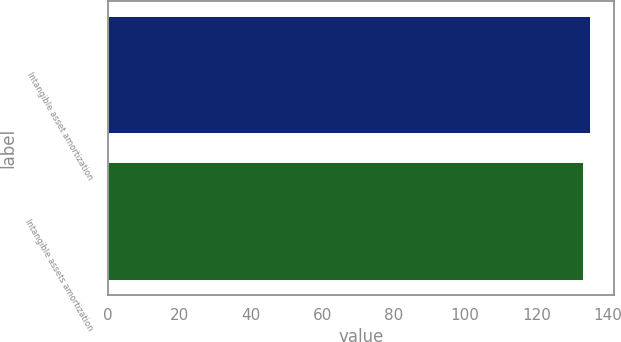Convert chart to OTSL. <chart><loc_0><loc_0><loc_500><loc_500><bar_chart><fcel>Intangible asset amortization<fcel>Intangible assets amortization<nl><fcel>135<fcel>133<nl></chart> 